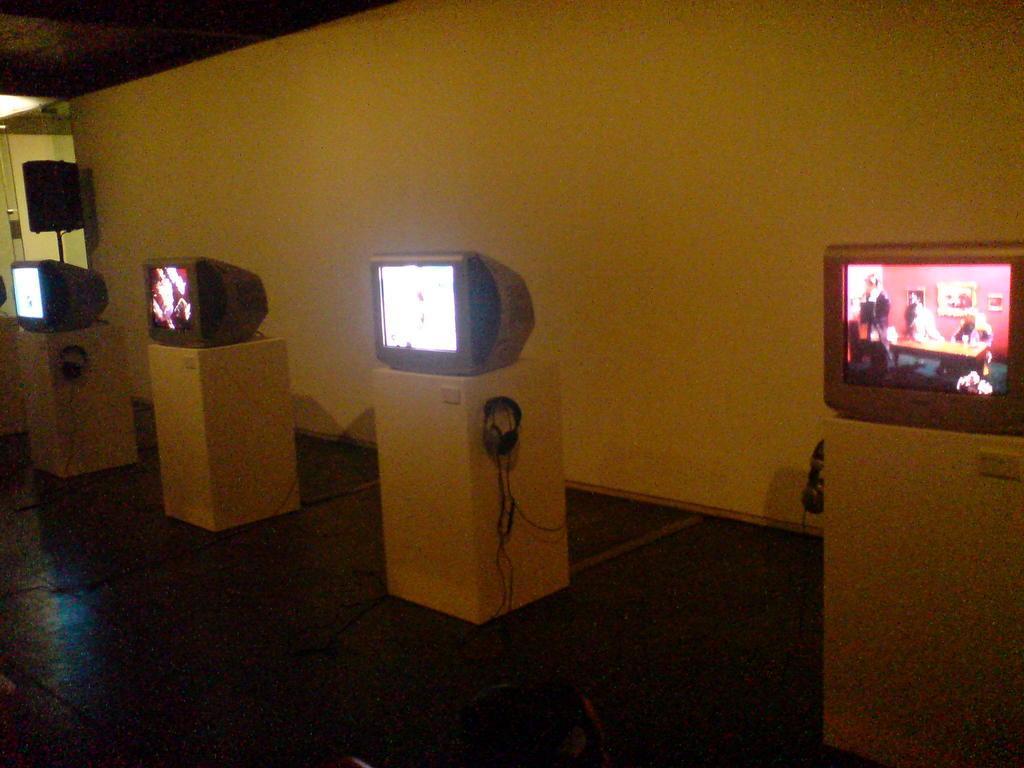Can you describe this image briefly? The picture is taken in a room. In the picture there are televisions and cables. In the background the wall is painted white. On the left there is a speaker and door. 